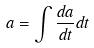Convert formula to latex. <formula><loc_0><loc_0><loc_500><loc_500>a = \int \frac { d a } { d t } d t</formula> 